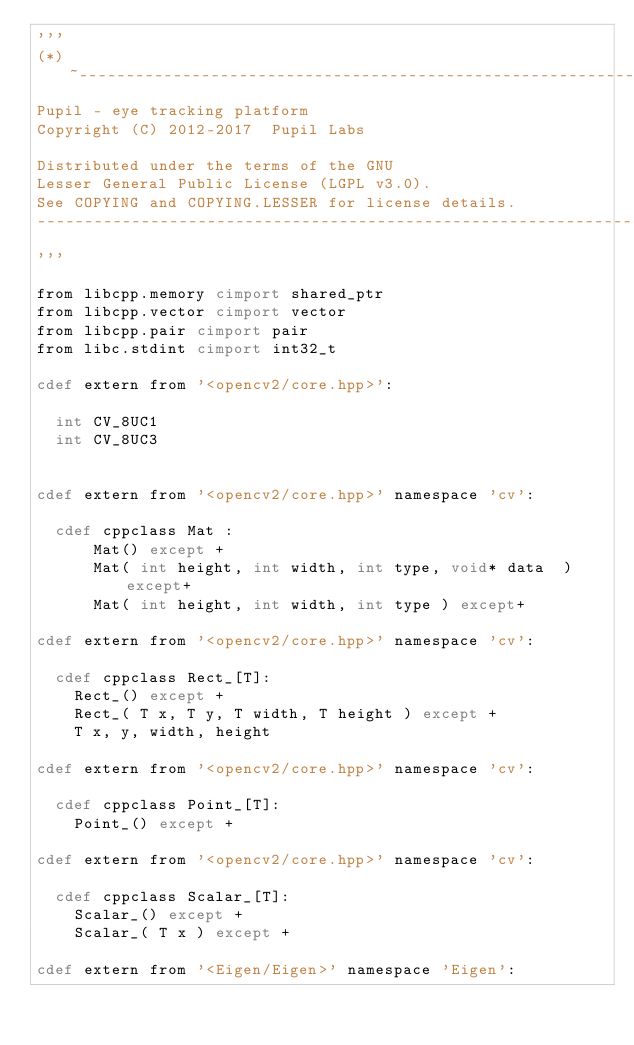<code> <loc_0><loc_0><loc_500><loc_500><_Cython_>'''
(*)~---------------------------------------------------------------------------
Pupil - eye tracking platform
Copyright (C) 2012-2017  Pupil Labs

Distributed under the terms of the GNU
Lesser General Public License (LGPL v3.0).
See COPYING and COPYING.LESSER for license details.
---------------------------------------------------------------------------~(*)
'''

from libcpp.memory cimport shared_ptr
from libcpp.vector cimport vector
from libcpp.pair cimport pair
from libc.stdint cimport int32_t

cdef extern from '<opencv2/core.hpp>':

  int CV_8UC1
  int CV_8UC3


cdef extern from '<opencv2/core.hpp>' namespace 'cv':

  cdef cppclass Mat :
      Mat() except +
      Mat( int height, int width, int type, void* data  ) except+
      Mat( int height, int width, int type ) except+

cdef extern from '<opencv2/core.hpp>' namespace 'cv':

  cdef cppclass Rect_[T]:
    Rect_() except +
    Rect_( T x, T y, T width, T height ) except +
    T x, y, width, height

cdef extern from '<opencv2/core.hpp>' namespace 'cv':

  cdef cppclass Point_[T]:
    Point_() except +

cdef extern from '<opencv2/core.hpp>' namespace 'cv':

  cdef cppclass Scalar_[T]:
    Scalar_() except +
    Scalar_( T x ) except +

cdef extern from '<Eigen/Eigen>' namespace 'Eigen':</code> 